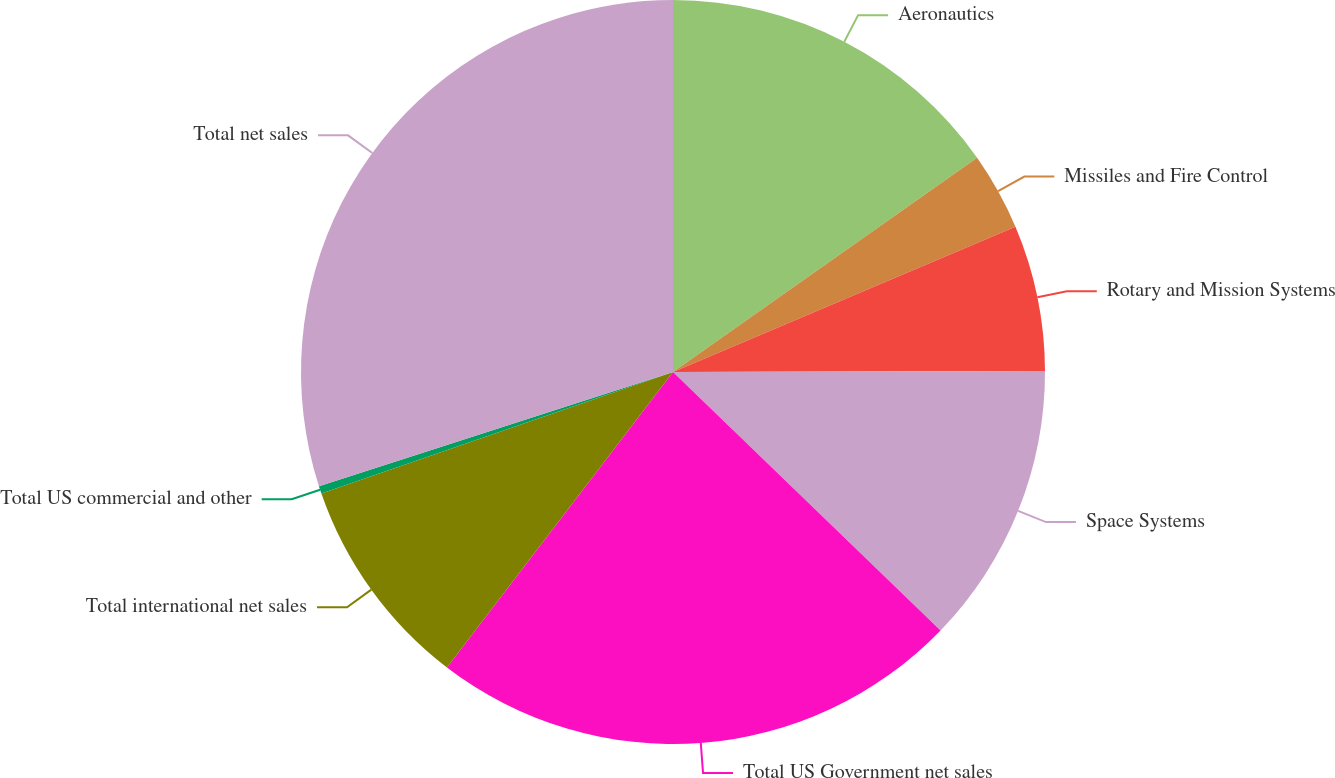<chart> <loc_0><loc_0><loc_500><loc_500><pie_chart><fcel>Aeronautics<fcel>Missiles and Fire Control<fcel>Rotary and Mission Systems<fcel>Space Systems<fcel>Total US Government net sales<fcel>Total international net sales<fcel>Total US commercial and other<fcel>Total net sales<nl><fcel>15.23%<fcel>3.38%<fcel>6.34%<fcel>12.27%<fcel>23.17%<fcel>9.31%<fcel>0.33%<fcel>29.96%<nl></chart> 